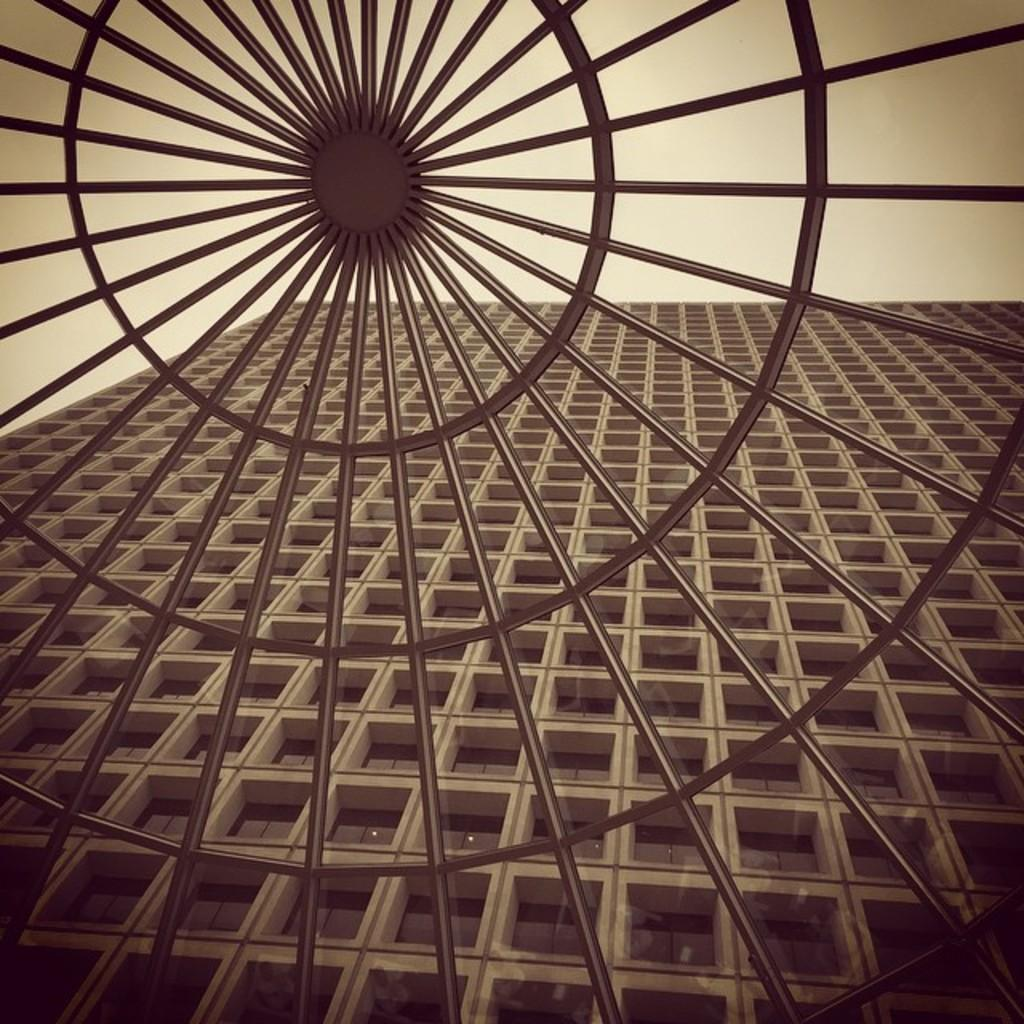What type of metal structure is present in the image? There is a wheel-like metal structure in the image. What can be seen through the metal structure? The metal structure allows a view of a multistory building. What is visible at the top of the image? The sky is visible at the top of the image. What type of pie is being served on the flowers near the hydrant in the image? There is no pie, flowers, or hydrant present in the image. 